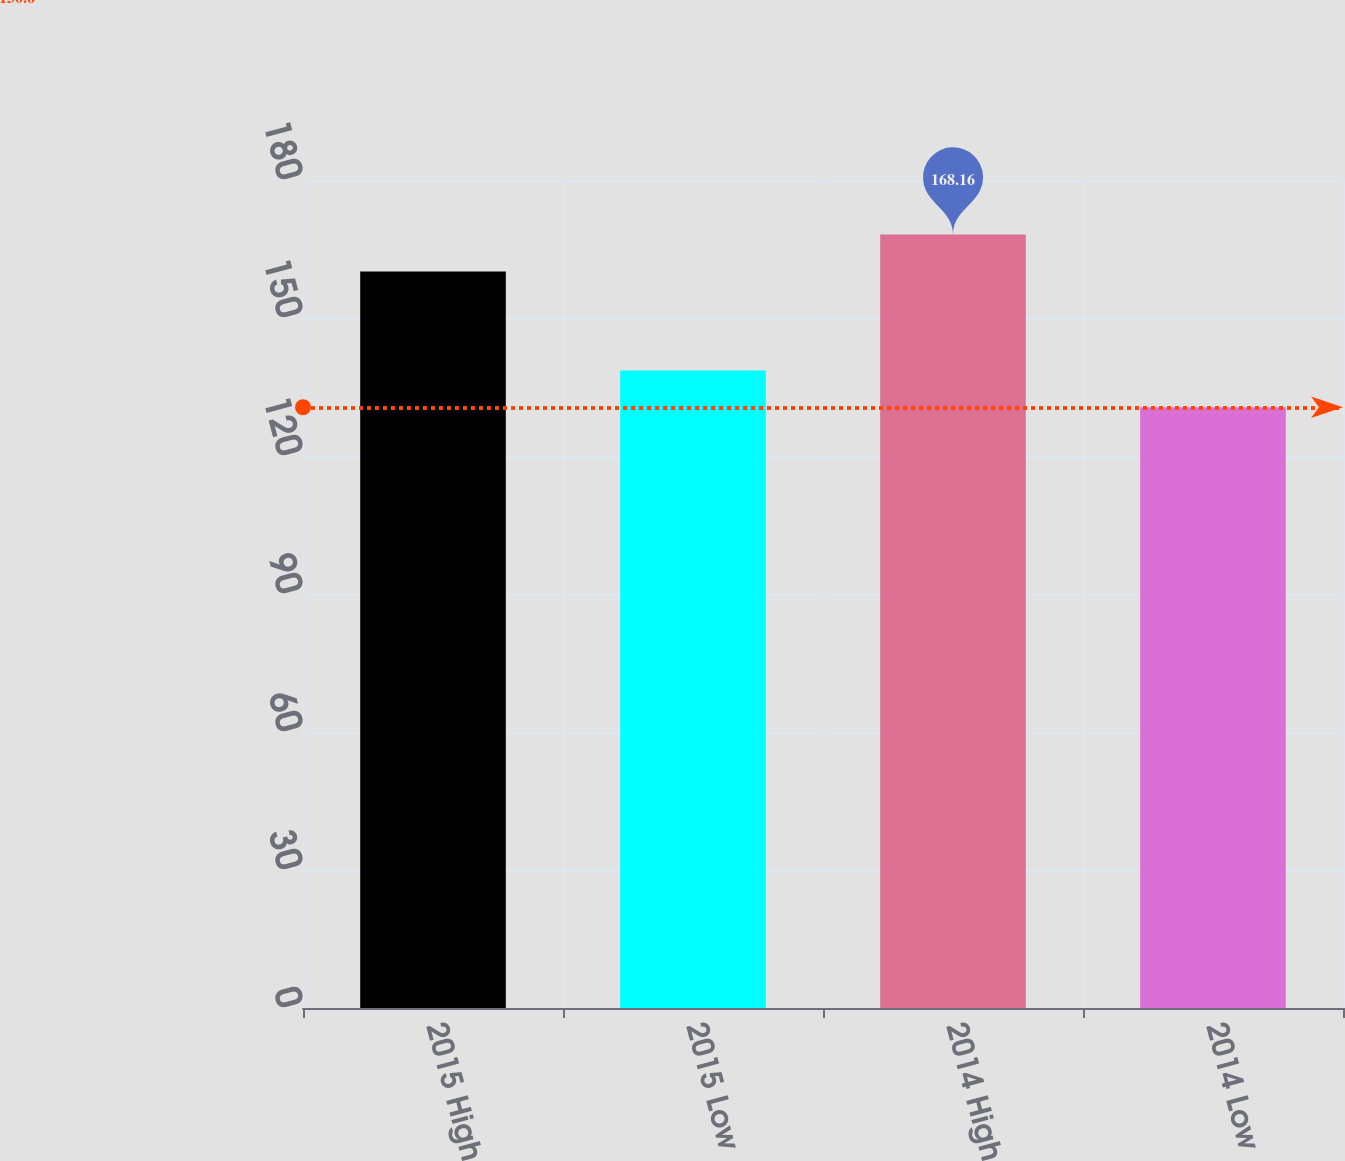Convert chart. <chart><loc_0><loc_0><loc_500><loc_500><bar_chart><fcel>2015 High<fcel>2015 Low<fcel>2014 High<fcel>2014 Low<nl><fcel>160.09<fcel>138.57<fcel>168.16<fcel>130.6<nl></chart> 